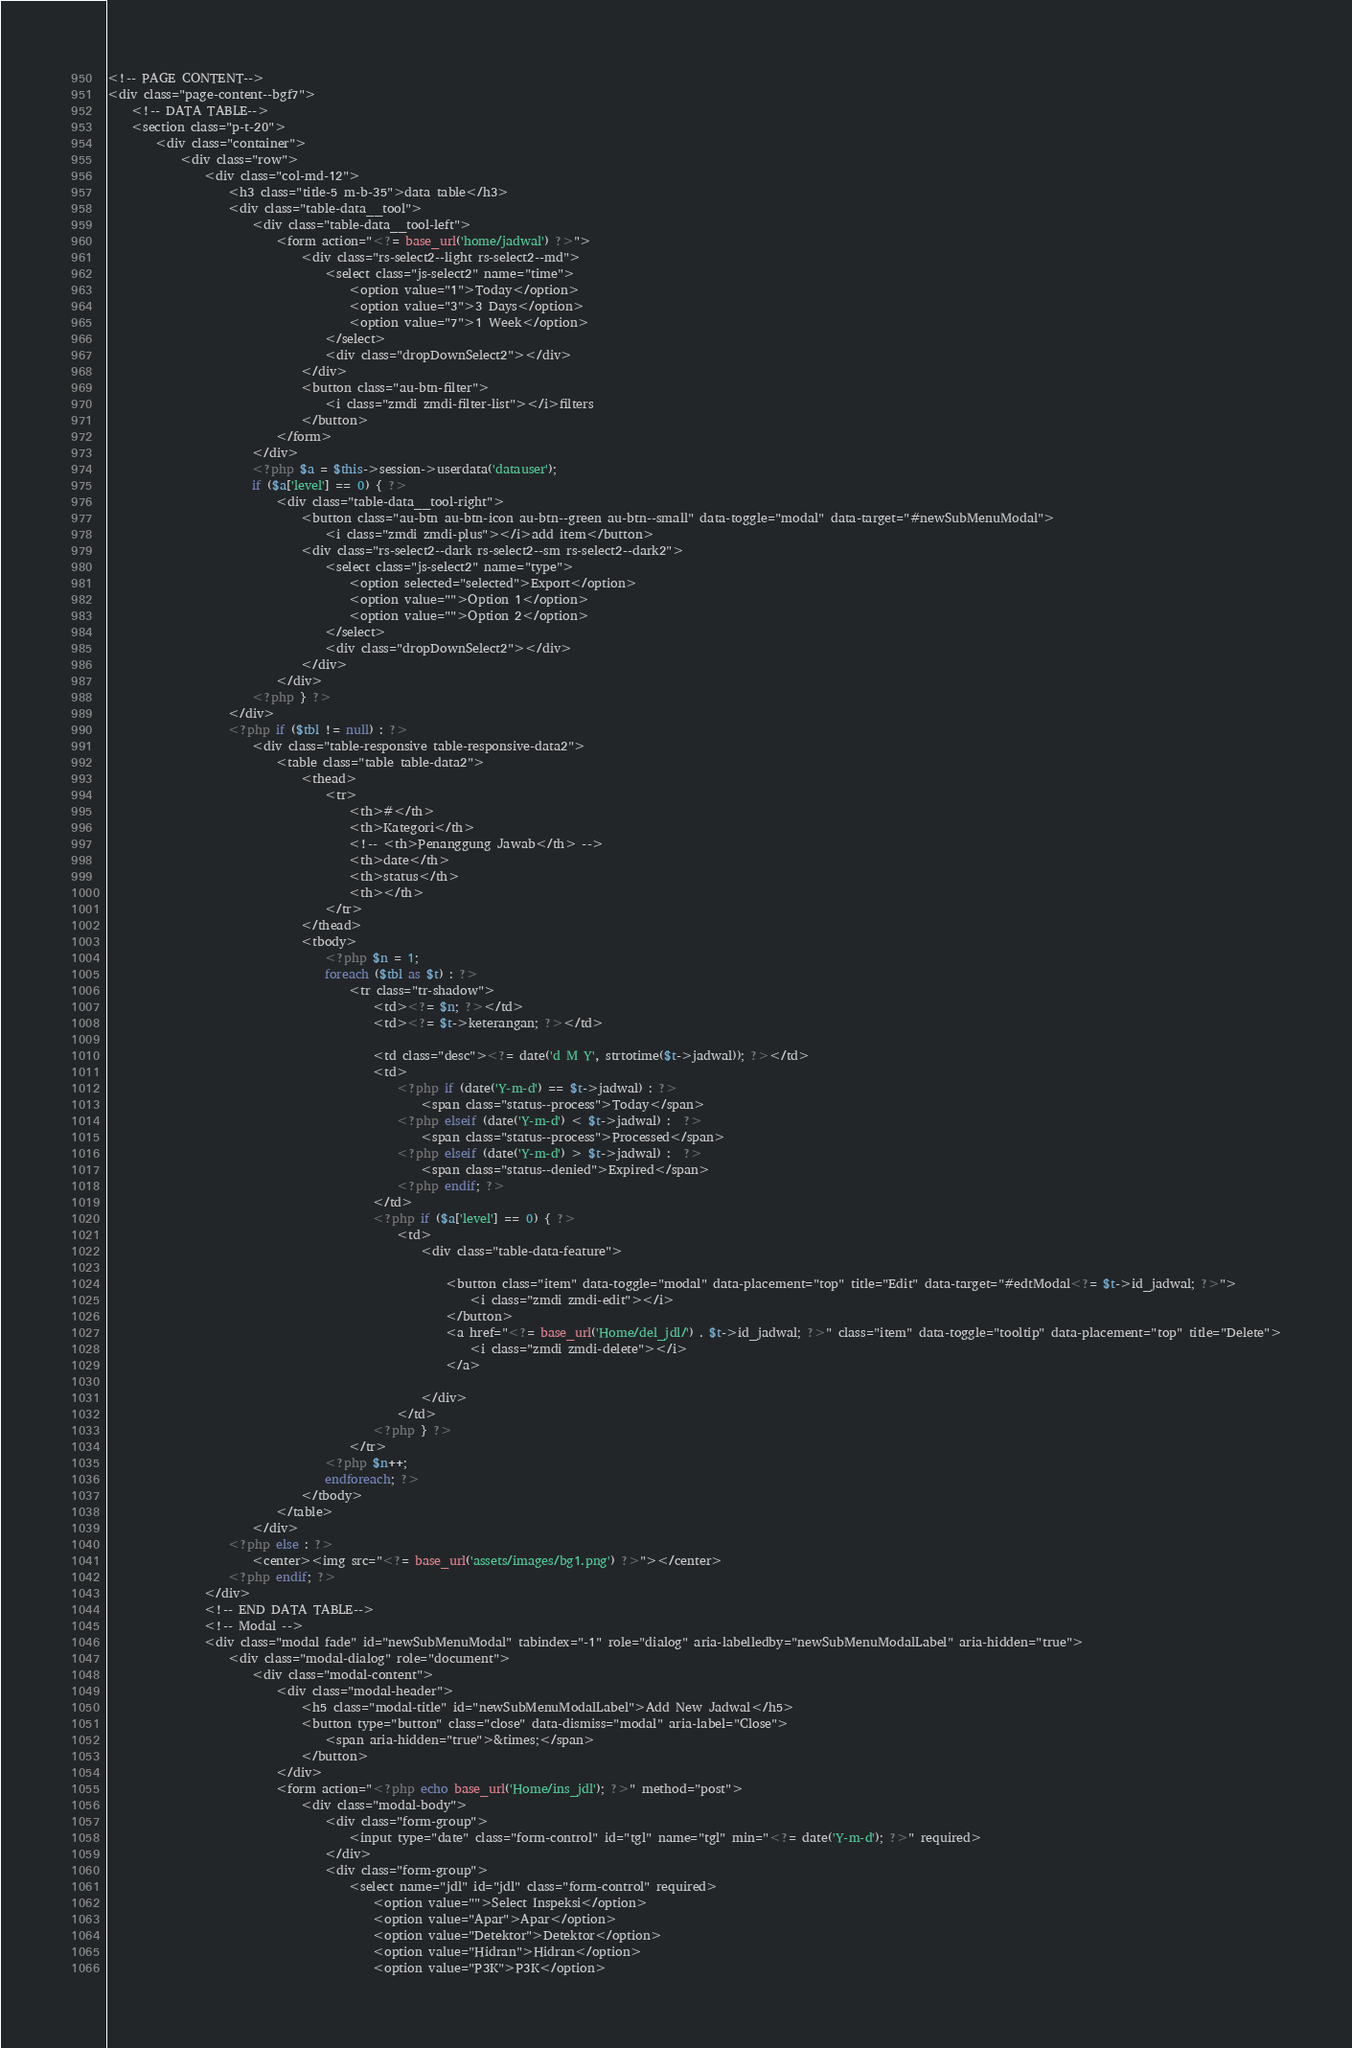Convert code to text. <code><loc_0><loc_0><loc_500><loc_500><_PHP_><!-- PAGE CONTENT-->
<div class="page-content--bgf7">
    <!-- DATA TABLE-->
    <section class="p-t-20">
        <div class="container">
            <div class="row">
                <div class="col-md-12">
                    <h3 class="title-5 m-b-35">data table</h3>
                    <div class="table-data__tool">
                        <div class="table-data__tool-left">
                            <form action="<?= base_url('home/jadwal') ?>">
                                <div class="rs-select2--light rs-select2--md">
                                    <select class="js-select2" name="time">
                                        <option value="1">Today</option>
                                        <option value="3">3 Days</option>
                                        <option value="7">1 Week</option>
                                    </select>
                                    <div class="dropDownSelect2"></div>
                                </div>
                                <button class="au-btn-filter">
                                    <i class="zmdi zmdi-filter-list"></i>filters
                                </button>
                            </form>
                        </div>
                        <?php $a = $this->session->userdata('datauser');
                        if ($a['level'] == 0) { ?>
                            <div class="table-data__tool-right">
                                <button class="au-btn au-btn-icon au-btn--green au-btn--small" data-toggle="modal" data-target="#newSubMenuModal">
                                    <i class="zmdi zmdi-plus"></i>add item</button>
                                <div class="rs-select2--dark rs-select2--sm rs-select2--dark2">
                                    <select class="js-select2" name="type">
                                        <option selected="selected">Export</option>
                                        <option value="">Option 1</option>
                                        <option value="">Option 2</option>
                                    </select>
                                    <div class="dropDownSelect2"></div>
                                </div>
                            </div>
                        <?php } ?>
                    </div>
                    <?php if ($tbl != null) : ?>
                        <div class="table-responsive table-responsive-data2">
                            <table class="table table-data2">
                                <thead>
                                    <tr>
                                        <th>#</th>
                                        <th>Kategori</th>
                                        <!-- <th>Penanggung Jawab</th> -->
                                        <th>date</th>
                                        <th>status</th>
                                        <th></th>
                                    </tr>
                                </thead>
                                <tbody>
                                    <?php $n = 1;
                                    foreach ($tbl as $t) : ?>
                                        <tr class="tr-shadow">
                                            <td><?= $n; ?></td>
                                            <td><?= $t->keterangan; ?></td>

                                            <td class="desc"><?= date('d M Y', strtotime($t->jadwal)); ?></td>
                                            <td>
                                                <?php if (date('Y-m-d') == $t->jadwal) : ?>
                                                    <span class="status--process">Today</span>
                                                <?php elseif (date('Y-m-d') < $t->jadwal) :  ?>
                                                    <span class="status--process">Processed</span>
                                                <?php elseif (date('Y-m-d') > $t->jadwal) :  ?>
                                                    <span class="status--denied">Expired</span>
                                                <?php endif; ?>
                                            </td>
                                            <?php if ($a['level'] == 0) { ?>
                                                <td>
                                                    <div class="table-data-feature">

                                                        <button class="item" data-toggle="modal" data-placement="top" title="Edit" data-target="#edtModal<?= $t->id_jadwal; ?>">
                                                            <i class="zmdi zmdi-edit"></i>
                                                        </button>
                                                        <a href="<?= base_url('Home/del_jdl/') . $t->id_jadwal; ?>" class="item" data-toggle="tooltip" data-placement="top" title="Delete">
                                                            <i class="zmdi zmdi-delete"></i>
                                                        </a>

                                                    </div>
                                                </td>
                                            <?php } ?>
                                        </tr>
                                    <?php $n++;
                                    endforeach; ?>
                                </tbody>
                            </table>
                        </div>
                    <?php else : ?>
                        <center><img src="<?= base_url('assets/images/bg1.png') ?>"></center>
                    <?php endif; ?>
                </div>
                <!-- END DATA TABLE-->
                <!-- Modal -->
                <div class="modal fade" id="newSubMenuModal" tabindex="-1" role="dialog" aria-labelledby="newSubMenuModalLabel" aria-hidden="true">
                    <div class="modal-dialog" role="document">
                        <div class="modal-content">
                            <div class="modal-header">
                                <h5 class="modal-title" id="newSubMenuModalLabel">Add New Jadwal</h5>
                                <button type="button" class="close" data-dismiss="modal" aria-label="Close">
                                    <span aria-hidden="true">&times;</span>
                                </button>
                            </div>
                            <form action="<?php echo base_url('Home/ins_jdl'); ?>" method="post">
                                <div class="modal-body">
                                    <div class="form-group">
                                        <input type="date" class="form-control" id="tgl" name="tgl" min="<?= date('Y-m-d'); ?>" required>
                                    </div>
                                    <div class="form-group">
                                        <select name="jdl" id="jdl" class="form-control" required>
                                            <option value="">Select Inspeksi</option>
                                            <option value="Apar">Apar</option>
                                            <option value="Detektor">Detektor</option>
                                            <option value="Hidran">Hidran</option>
                                            <option value="P3K">P3K</option></code> 